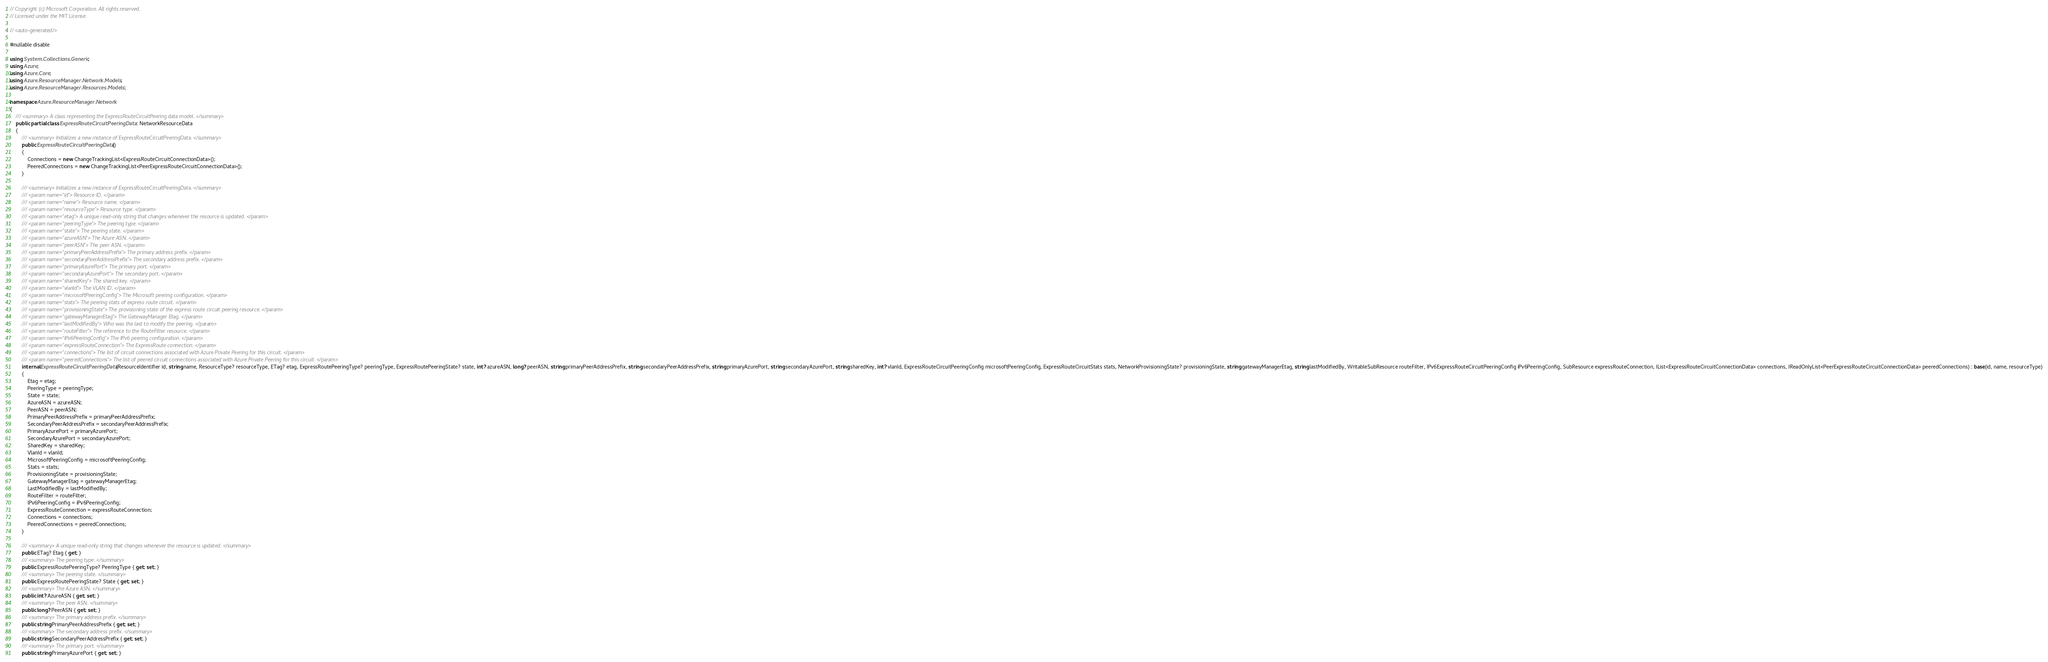<code> <loc_0><loc_0><loc_500><loc_500><_C#_>// Copyright (c) Microsoft Corporation. All rights reserved.
// Licensed under the MIT License.

// <auto-generated/>

#nullable disable

using System.Collections.Generic;
using Azure;
using Azure.Core;
using Azure.ResourceManager.Network.Models;
using Azure.ResourceManager.Resources.Models;

namespace Azure.ResourceManager.Network
{
    /// <summary> A class representing the ExpressRouteCircuitPeering data model. </summary>
    public partial class ExpressRouteCircuitPeeringData : NetworkResourceData
    {
        /// <summary> Initializes a new instance of ExpressRouteCircuitPeeringData. </summary>
        public ExpressRouteCircuitPeeringData()
        {
            Connections = new ChangeTrackingList<ExpressRouteCircuitConnectionData>();
            PeeredConnections = new ChangeTrackingList<PeerExpressRouteCircuitConnectionData>();
        }

        /// <summary> Initializes a new instance of ExpressRouteCircuitPeeringData. </summary>
        /// <param name="id"> Resource ID. </param>
        /// <param name="name"> Resource name. </param>
        /// <param name="resourceType"> Resource type. </param>
        /// <param name="etag"> A unique read-only string that changes whenever the resource is updated. </param>
        /// <param name="peeringType"> The peering type. </param>
        /// <param name="state"> The peering state. </param>
        /// <param name="azureASN"> The Azure ASN. </param>
        /// <param name="peerASN"> The peer ASN. </param>
        /// <param name="primaryPeerAddressPrefix"> The primary address prefix. </param>
        /// <param name="secondaryPeerAddressPrefix"> The secondary address prefix. </param>
        /// <param name="primaryAzurePort"> The primary port. </param>
        /// <param name="secondaryAzurePort"> The secondary port. </param>
        /// <param name="sharedKey"> The shared key. </param>
        /// <param name="vlanId"> The VLAN ID. </param>
        /// <param name="microsoftPeeringConfig"> The Microsoft peering configuration. </param>
        /// <param name="stats"> The peering stats of express route circuit. </param>
        /// <param name="provisioningState"> The provisioning state of the express route circuit peering resource. </param>
        /// <param name="gatewayManagerEtag"> The GatewayManager Etag. </param>
        /// <param name="lastModifiedBy"> Who was the last to modify the peering. </param>
        /// <param name="routeFilter"> The reference to the RouteFilter resource. </param>
        /// <param name="iPv6PeeringConfig"> The IPv6 peering configuration. </param>
        /// <param name="expressRouteConnection"> The ExpressRoute connection. </param>
        /// <param name="connections"> The list of circuit connections associated with Azure Private Peering for this circuit. </param>
        /// <param name="peeredConnections"> The list of peered circuit connections associated with Azure Private Peering for this circuit. </param>
        internal ExpressRouteCircuitPeeringData(ResourceIdentifier id, string name, ResourceType? resourceType, ETag? etag, ExpressRoutePeeringType? peeringType, ExpressRoutePeeringState? state, int? azureASN, long? peerASN, string primaryPeerAddressPrefix, string secondaryPeerAddressPrefix, string primaryAzurePort, string secondaryAzurePort, string sharedKey, int? vlanId, ExpressRouteCircuitPeeringConfig microsoftPeeringConfig, ExpressRouteCircuitStats stats, NetworkProvisioningState? provisioningState, string gatewayManagerEtag, string lastModifiedBy, WritableSubResource routeFilter, IPv6ExpressRouteCircuitPeeringConfig iPv6PeeringConfig, SubResource expressRouteConnection, IList<ExpressRouteCircuitConnectionData> connections, IReadOnlyList<PeerExpressRouteCircuitConnectionData> peeredConnections) : base(id, name, resourceType)
        {
            Etag = etag;
            PeeringType = peeringType;
            State = state;
            AzureASN = azureASN;
            PeerASN = peerASN;
            PrimaryPeerAddressPrefix = primaryPeerAddressPrefix;
            SecondaryPeerAddressPrefix = secondaryPeerAddressPrefix;
            PrimaryAzurePort = primaryAzurePort;
            SecondaryAzurePort = secondaryAzurePort;
            SharedKey = sharedKey;
            VlanId = vlanId;
            MicrosoftPeeringConfig = microsoftPeeringConfig;
            Stats = stats;
            ProvisioningState = provisioningState;
            GatewayManagerEtag = gatewayManagerEtag;
            LastModifiedBy = lastModifiedBy;
            RouteFilter = routeFilter;
            IPv6PeeringConfig = iPv6PeeringConfig;
            ExpressRouteConnection = expressRouteConnection;
            Connections = connections;
            PeeredConnections = peeredConnections;
        }

        /// <summary> A unique read-only string that changes whenever the resource is updated. </summary>
        public ETag? Etag { get; }
        /// <summary> The peering type. </summary>
        public ExpressRoutePeeringType? PeeringType { get; set; }
        /// <summary> The peering state. </summary>
        public ExpressRoutePeeringState? State { get; set; }
        /// <summary> The Azure ASN. </summary>
        public int? AzureASN { get; set; }
        /// <summary> The peer ASN. </summary>
        public long? PeerASN { get; set; }
        /// <summary> The primary address prefix. </summary>
        public string PrimaryPeerAddressPrefix { get; set; }
        /// <summary> The secondary address prefix. </summary>
        public string SecondaryPeerAddressPrefix { get; set; }
        /// <summary> The primary port. </summary>
        public string PrimaryAzurePort { get; set; }</code> 